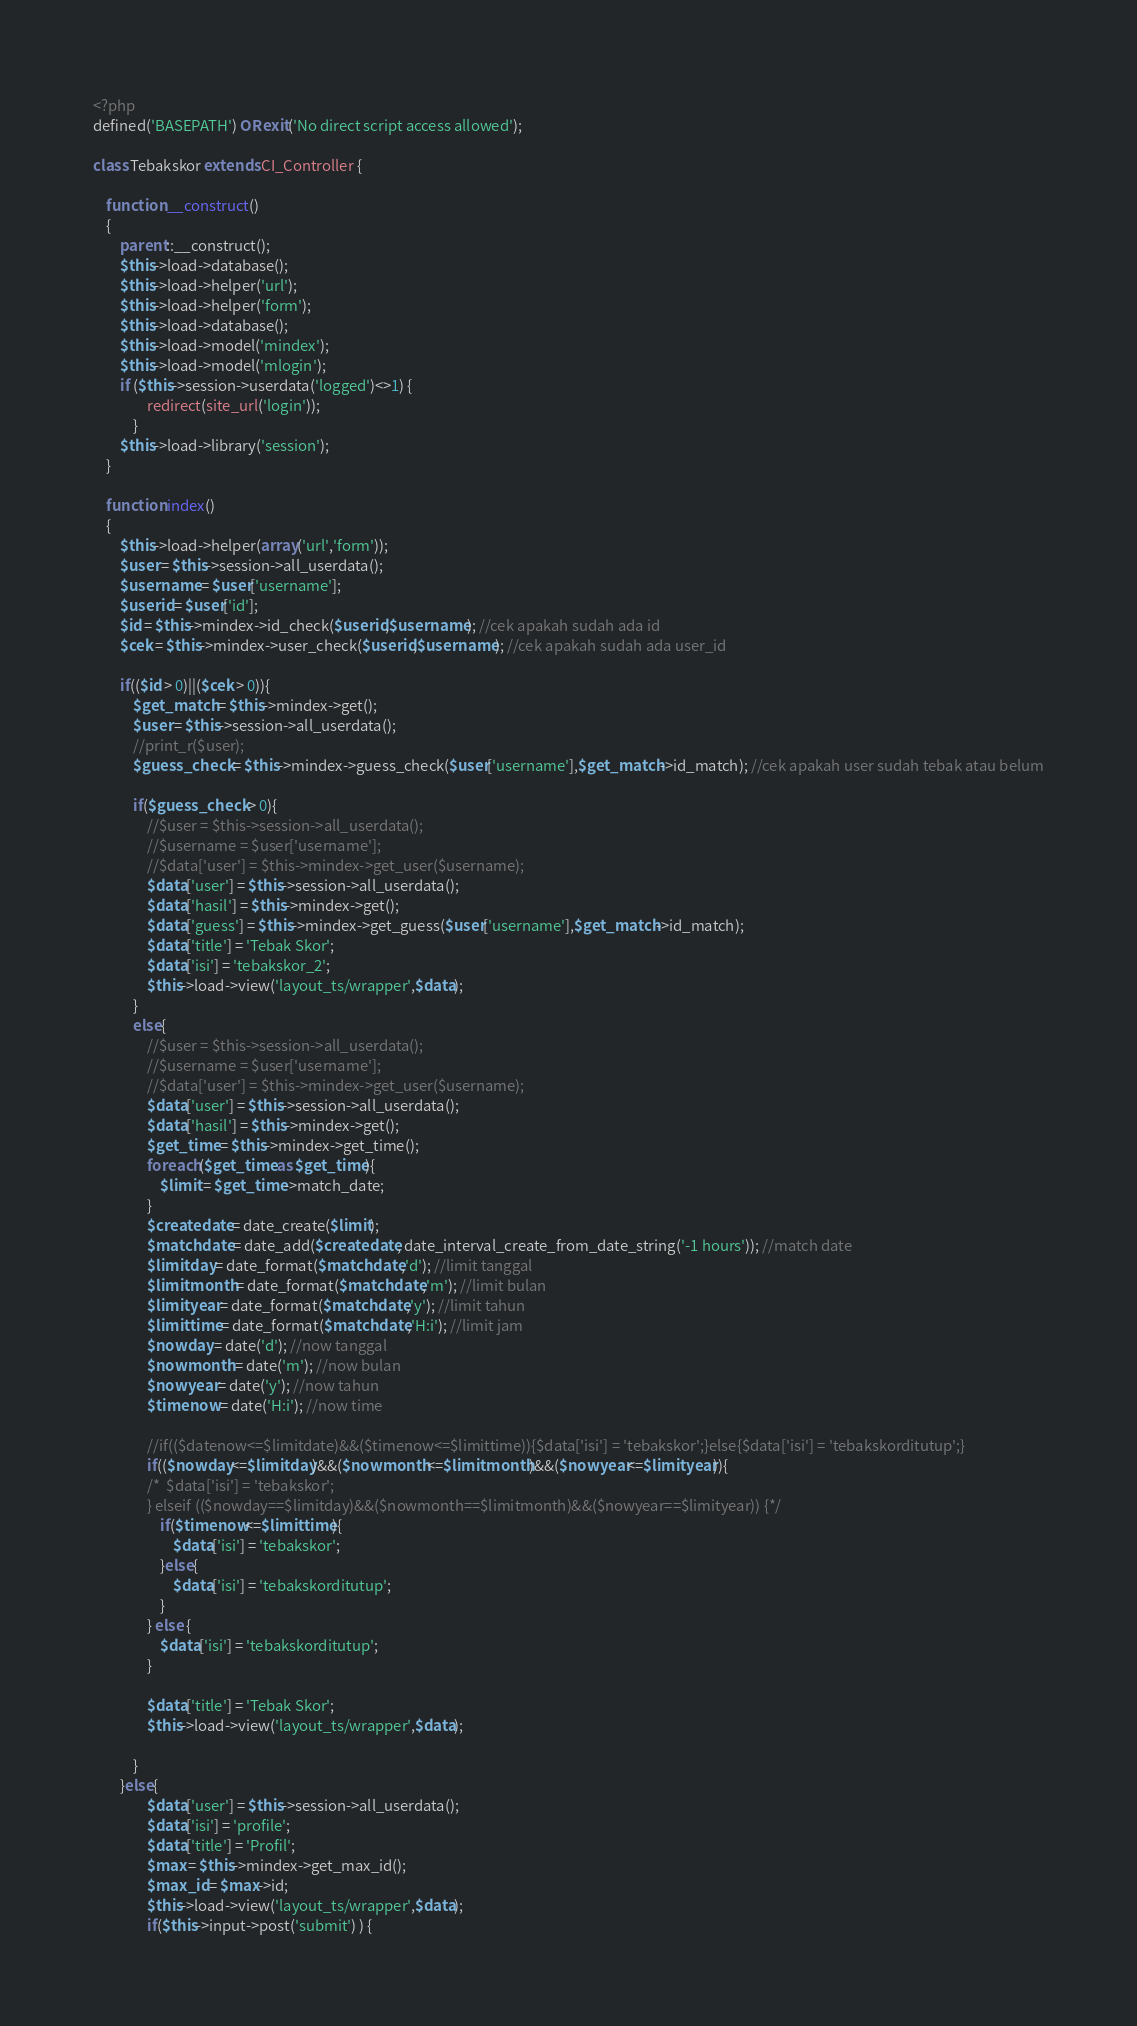<code> <loc_0><loc_0><loc_500><loc_500><_PHP_><?php
defined('BASEPATH') OR exit('No direct script access allowed');

class Tebakskor extends CI_Controller {

	function __construct()
    {
        parent::__construct();
        $this->load->database();
        $this->load->helper('url');
        $this->load->helper('form');
        $this->load->database();
        $this->load->model('mindex');
        $this->load->model('mlogin');
		if ($this->session->userdata('logged')<>1) {
                redirect(site_url('login'));
            }
		$this->load->library('session');
    }

    function index()
    {
		$this->load->helper(array('url','form'));
		$user = $this->session->all_userdata();
		$username = $user['username'];
		$userid = $user['id'];
		$id = $this->mindex->id_check($userid,$username); //cek apakah sudah ada id
		$cek = $this->mindex->user_check($userid,$username); //cek apakah sudah ada user_id
		
		if(($id > 0)||($cek > 0)){
			$get_match = $this->mindex->get();
			$user = $this->session->all_userdata();
			//print_r($user);
			$guess_check = $this->mindex->guess_check($user['username'],$get_match->id_match); //cek apakah user sudah tebak atau belum
			
			if($guess_check > 0){
				//$user = $this->session->all_userdata();
				//$username = $user['username'];
				//$data['user'] = $this->mindex->get_user($username);
				$data['user'] = $this->session->all_userdata();
				$data['hasil'] = $this->mindex->get();
				$data['guess'] = $this->mindex->get_guess($user['username'],$get_match->id_match);
				$data['title'] = 'Tebak Skor';
				$data['isi'] = 'tebakskor_2';
				$this->load->view('layout_ts/wrapper',$data);
			}
			else{
				//$user = $this->session->all_userdata();
				//$username = $user['username'];
				//$data['user'] = $this->mindex->get_user($username);
				$data['user'] = $this->session->all_userdata();
				$data['hasil'] = $this->mindex->get();
				$get_time = $this->mindex->get_time();
				foreach($get_time as $get_time){
					$limit = $get_time->match_date;
				}
				$createdate = date_create($limit);
				$matchdate = date_add($createdate, date_interval_create_from_date_string('-1 hours')); //match date
				$limitday = date_format($matchdate,'d'); //limit tanggal 
				$limitmonth = date_format($matchdate,'m'); //limit bulan 
				$limityear = date_format($matchdate,'y'); //limit tahun
				$limittime = date_format($matchdate,'H:i'); //limit jam
				$nowday = date('d'); //now tanggal
				$nowmonth = date('m'); //now bulan
				$nowyear = date('y'); //now tahun
				$timenow = date('H:i'); //now time
				
				//if(($datenow<=$limitdate)&&($timenow<=$limittime)){$data['isi'] = 'tebakskor';}else{$data['isi'] = 'tebakskorditutup';}
				if(($nowday<=$limitday)&&($nowmonth<=$limitmonth)&&($nowyear<=$limityear)){
				/*	$data['isi'] = 'tebakskor';
				} elseif (($nowday==$limitday)&&($nowmonth==$limitmonth)&&($nowyear==$limityear)) {*/
					if($timenow<=$limittime){
						$data['isi'] = 'tebakskor';
					}else{
						$data['isi'] = 'tebakskorditutup';
					}
				} else {
					$data['isi'] = 'tebakskorditutup';
				}
				
				$data['title'] = 'Tebak Skor';
				$this->load->view('layout_ts/wrapper',$data);
			
			}
		}else{
				$data['user'] = $this->session->all_userdata();
				$data['isi'] = 'profile';
				$data['title'] = 'Profil';
				$max = $this->mindex->get_max_id();
				$max_id = $max->id;
				$this->load->view('layout_ts/wrapper',$data); 
				if($this->input->post('submit') ) {</code> 